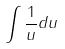<formula> <loc_0><loc_0><loc_500><loc_500>\int \frac { 1 } { u } d u</formula> 